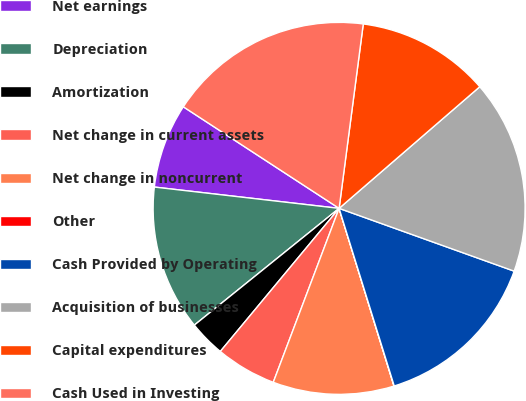<chart> <loc_0><loc_0><loc_500><loc_500><pie_chart><fcel>Net earnings<fcel>Depreciation<fcel>Amortization<fcel>Net change in current assets<fcel>Net change in noncurrent<fcel>Other<fcel>Cash Provided by Operating<fcel>Acquisition of businesses<fcel>Capital expenditures<fcel>Cash Used in Investing<nl><fcel>7.37%<fcel>12.63%<fcel>3.17%<fcel>5.27%<fcel>10.53%<fcel>0.02%<fcel>14.73%<fcel>16.83%<fcel>11.58%<fcel>17.88%<nl></chart> 